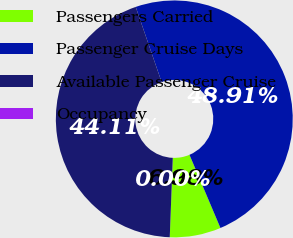Convert chart to OTSL. <chart><loc_0><loc_0><loc_500><loc_500><pie_chart><fcel>Passengers Carried<fcel>Passenger Cruise Days<fcel>Available Passenger Cruise<fcel>Occupancy<nl><fcel>6.98%<fcel>48.91%<fcel>44.11%<fcel>0.0%<nl></chart> 